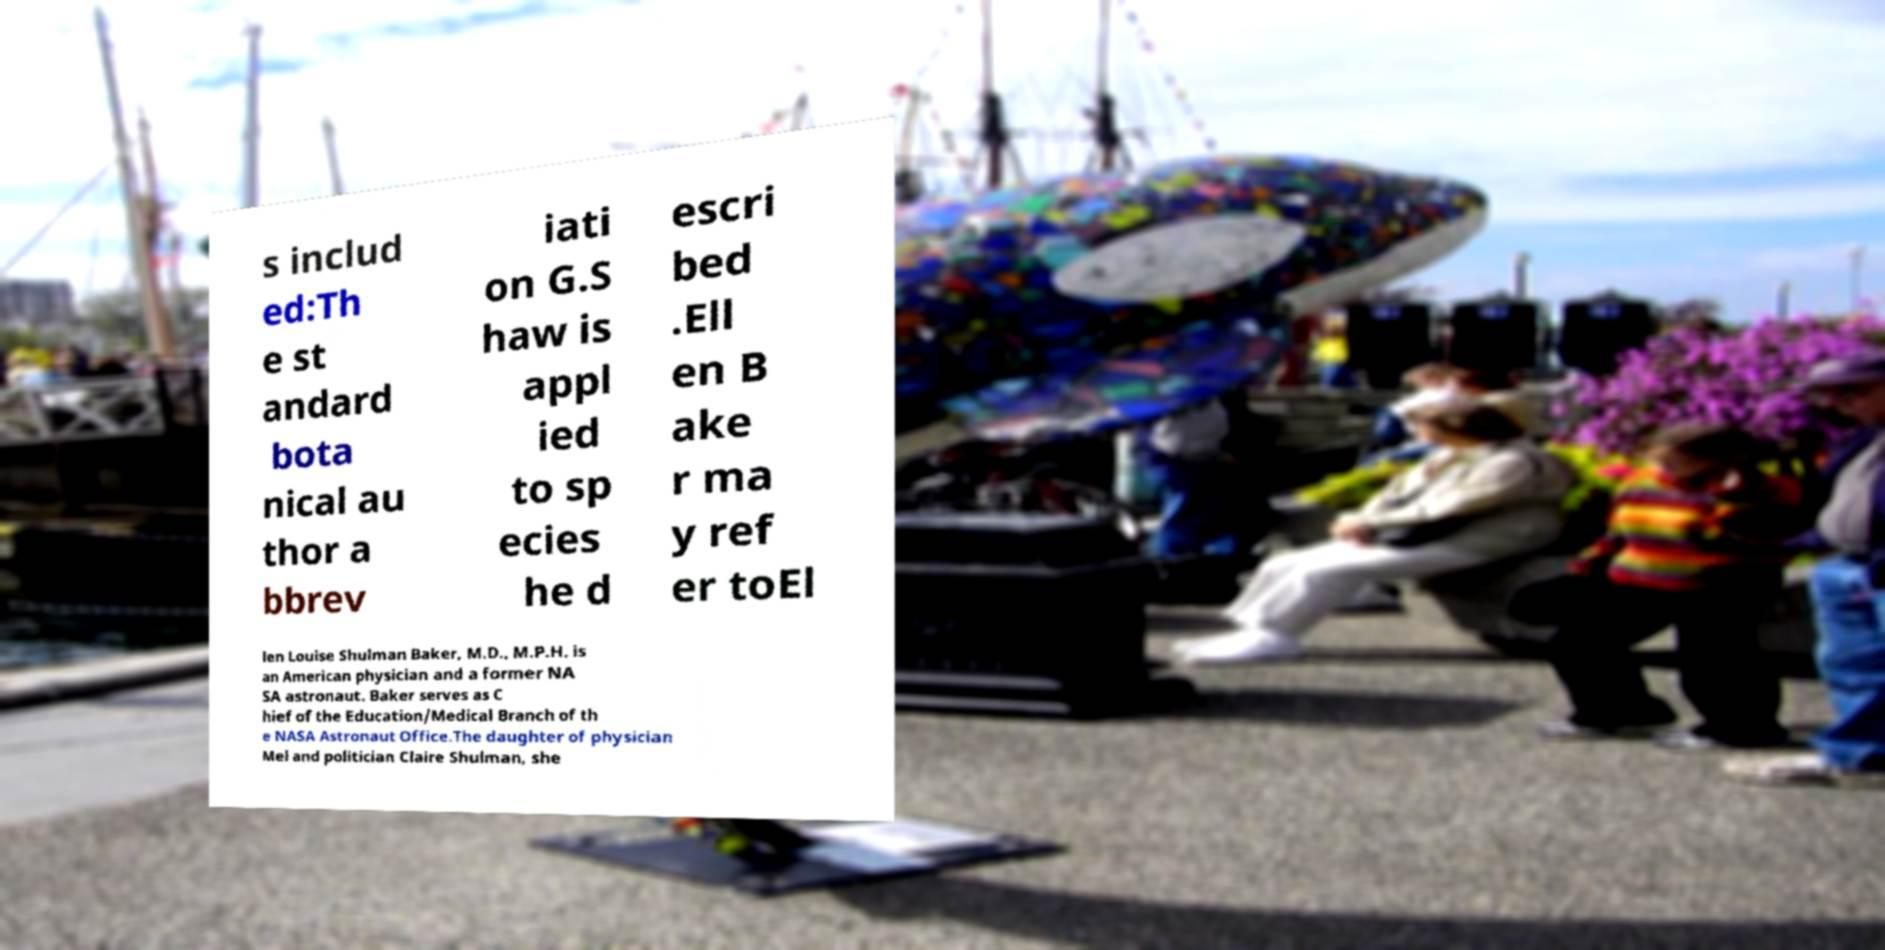Could you extract and type out the text from this image? s includ ed:Th e st andard bota nical au thor a bbrev iati on G.S haw is appl ied to sp ecies he d escri bed .Ell en B ake r ma y ref er toEl len Louise Shulman Baker, M.D., M.P.H. is an American physician and a former NA SA astronaut. Baker serves as C hief of the Education/Medical Branch of th e NASA Astronaut Office.The daughter of physician Mel and politician Claire Shulman, she 